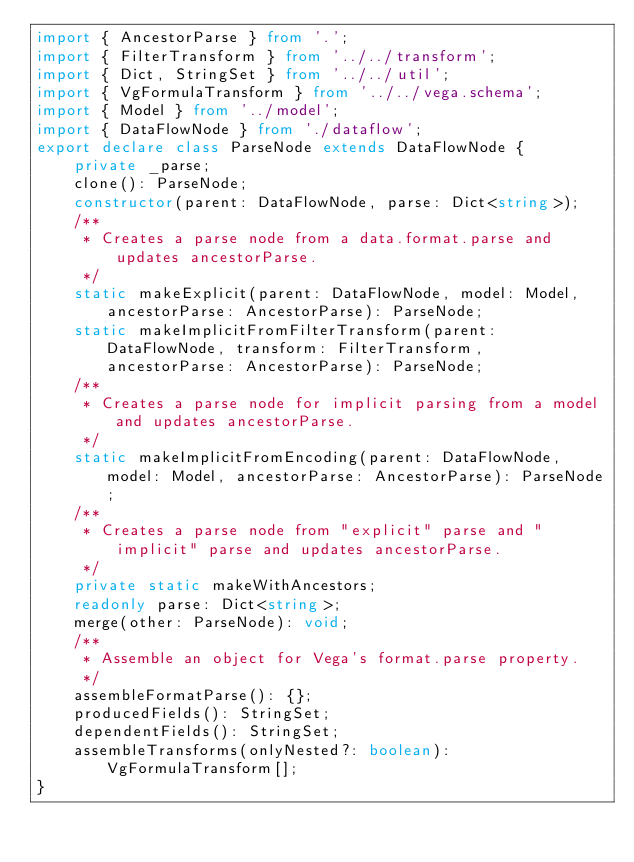<code> <loc_0><loc_0><loc_500><loc_500><_TypeScript_>import { AncestorParse } from '.';
import { FilterTransform } from '../../transform';
import { Dict, StringSet } from '../../util';
import { VgFormulaTransform } from '../../vega.schema';
import { Model } from '../model';
import { DataFlowNode } from './dataflow';
export declare class ParseNode extends DataFlowNode {
    private _parse;
    clone(): ParseNode;
    constructor(parent: DataFlowNode, parse: Dict<string>);
    /**
     * Creates a parse node from a data.format.parse and updates ancestorParse.
     */
    static makeExplicit(parent: DataFlowNode, model: Model, ancestorParse: AncestorParse): ParseNode;
    static makeImplicitFromFilterTransform(parent: DataFlowNode, transform: FilterTransform, ancestorParse: AncestorParse): ParseNode;
    /**
     * Creates a parse node for implicit parsing from a model and updates ancestorParse.
     */
    static makeImplicitFromEncoding(parent: DataFlowNode, model: Model, ancestorParse: AncestorParse): ParseNode;
    /**
     * Creates a parse node from "explicit" parse and "implicit" parse and updates ancestorParse.
     */
    private static makeWithAncestors;
    readonly parse: Dict<string>;
    merge(other: ParseNode): void;
    /**
     * Assemble an object for Vega's format.parse property.
     */
    assembleFormatParse(): {};
    producedFields(): StringSet;
    dependentFields(): StringSet;
    assembleTransforms(onlyNested?: boolean): VgFormulaTransform[];
}
</code> 